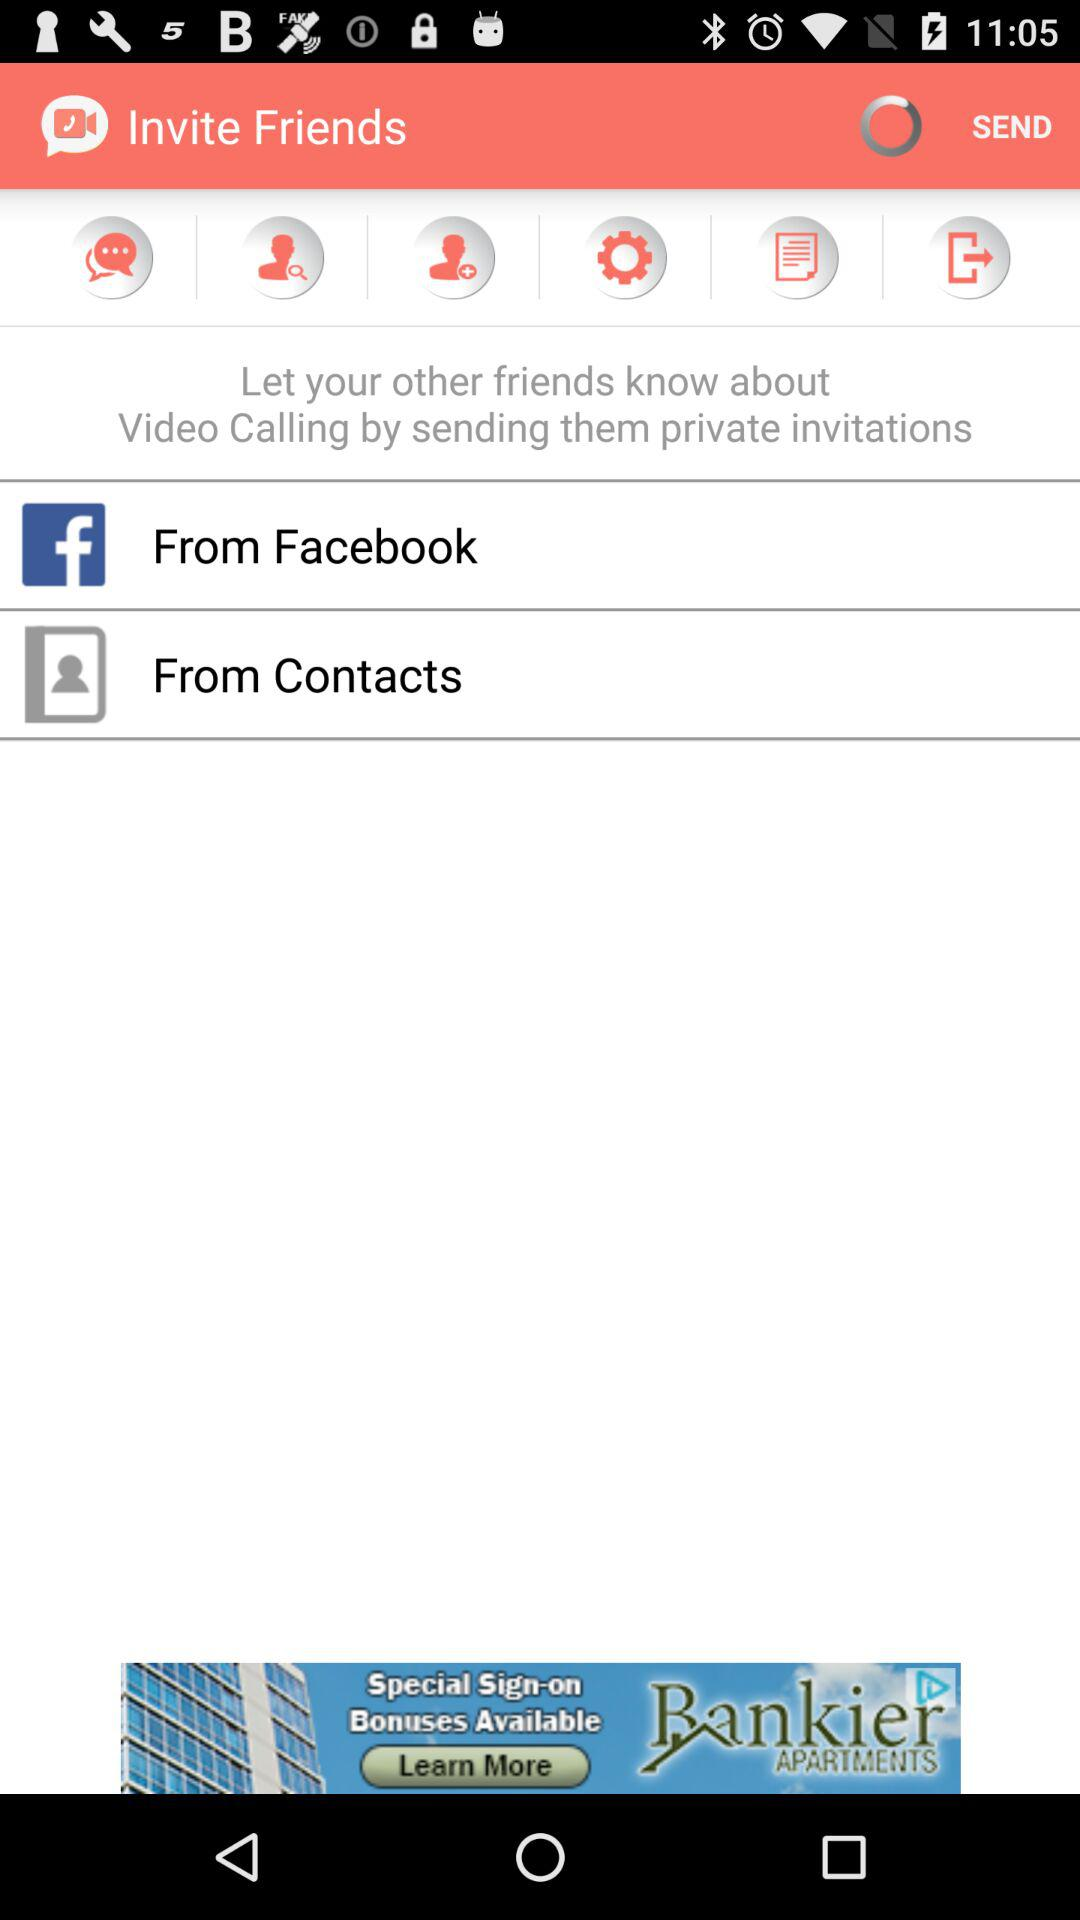How many sources can I invite friends from?
Answer the question using a single word or phrase. 2 